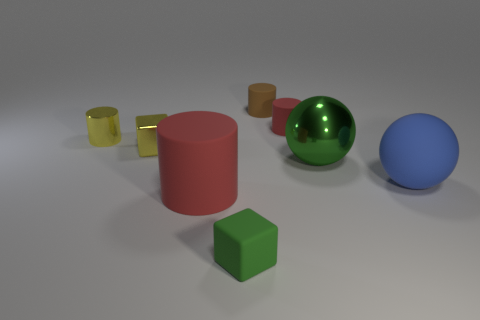The metal object that is the same color as the tiny shiny cube is what shape?
Make the answer very short. Cylinder. What is the material of the big red object?
Your answer should be compact. Rubber. Is the number of large matte spheres behind the tiny yellow metallic cube greater than the number of rubber cylinders?
Keep it short and to the point. No. Are any green rubber spheres visible?
Keep it short and to the point. No. How many other things are there of the same shape as the large blue rubber object?
Provide a succinct answer. 1. Do the small matte cylinder that is in front of the tiny brown cylinder and the small matte object that is on the left side of the brown matte thing have the same color?
Your response must be concise. No. What size is the red rubber cylinder behind the large matte thing on the left side of the large green metal sphere on the right side of the large red object?
Provide a short and direct response. Small. There is a object that is both in front of the large blue rubber sphere and behind the small green block; what shape is it?
Make the answer very short. Cylinder. Is the number of blue matte spheres in front of the tiny brown cylinder the same as the number of small yellow things behind the small yellow shiny cylinder?
Provide a short and direct response. No. Are there any large red objects made of the same material as the tiny yellow cylinder?
Ensure brevity in your answer.  No. 